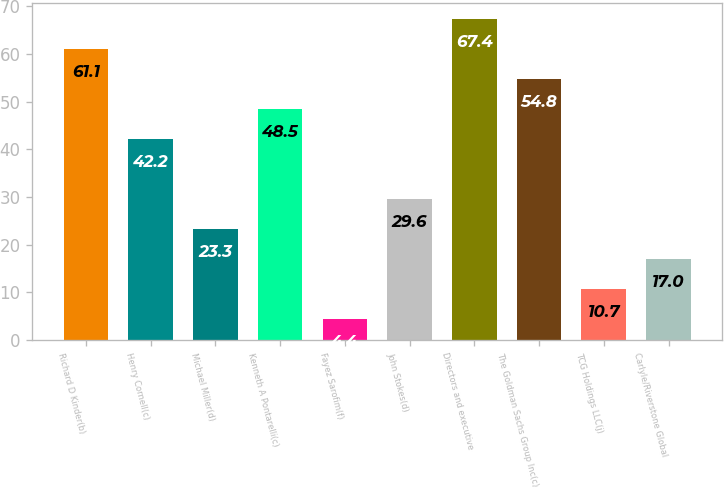<chart> <loc_0><loc_0><loc_500><loc_500><bar_chart><fcel>Richard D Kinder(b)<fcel>Henry Cornell(c)<fcel>Michael Miller(d)<fcel>Kenneth A Pontarelli(c)<fcel>Fayez Sarofim(f)<fcel>John Stokes(d)<fcel>Directors and executive<fcel>The Goldman Sachs Group Inc(c)<fcel>TCG Holdings LLC(j)<fcel>Carlyle/Riverstone Global<nl><fcel>61.1<fcel>42.2<fcel>23.3<fcel>48.5<fcel>4.4<fcel>29.6<fcel>67.4<fcel>54.8<fcel>10.7<fcel>17<nl></chart> 